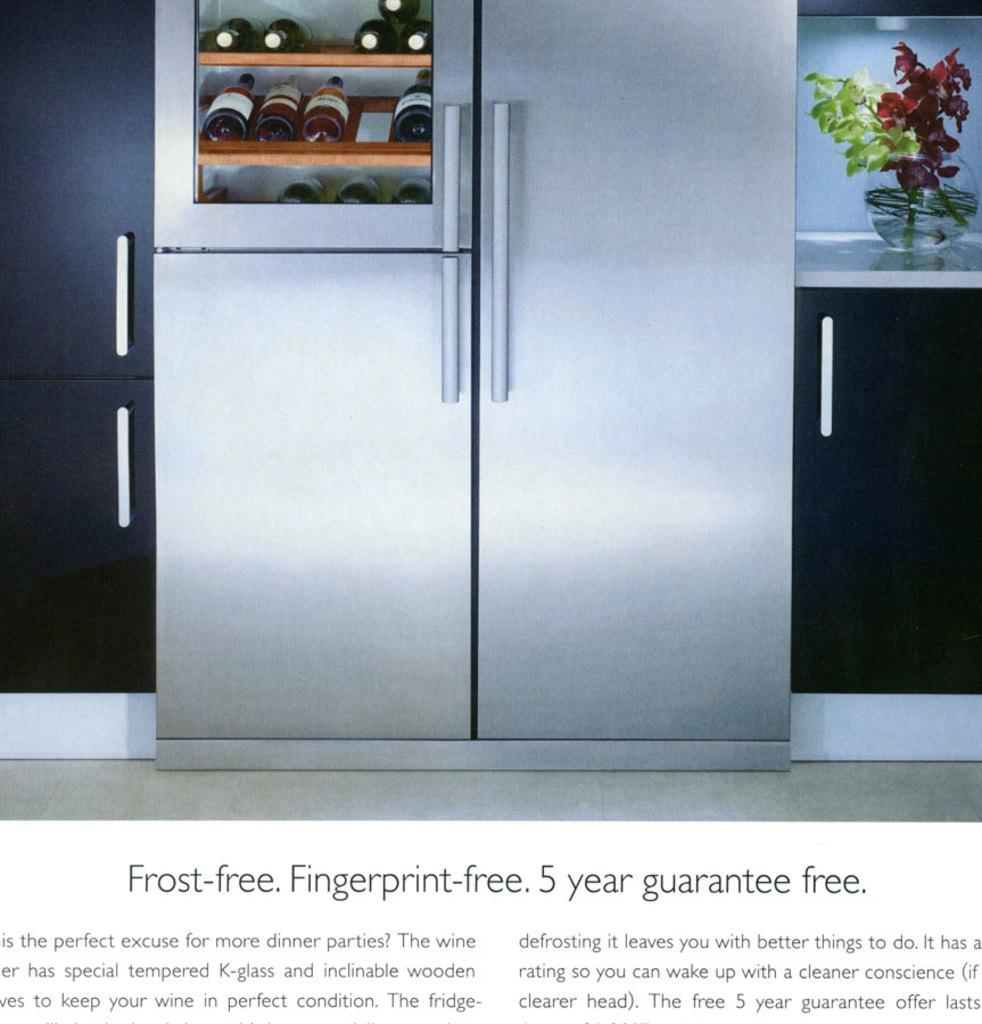Provide a one-sentence caption for the provided image. An advertisement for a fingerprint free fridge with a 5 year guarantee. 